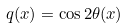Convert formula to latex. <formula><loc_0><loc_0><loc_500><loc_500>q ( x ) = \cos 2 \theta ( x ) \</formula> 